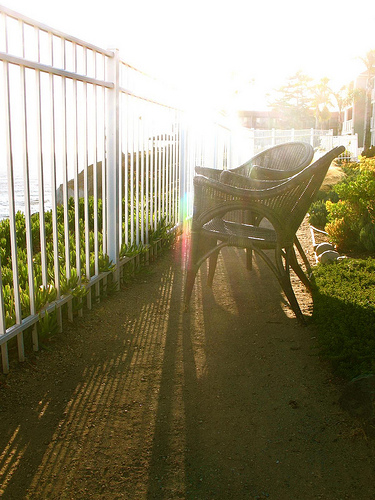<image>
Can you confirm if the fence is behind the chair? No. The fence is not behind the chair. From this viewpoint, the fence appears to be positioned elsewhere in the scene. Is the chair on the fence? No. The chair is not positioned on the fence. They may be near each other, but the chair is not supported by or resting on top of the fence. 